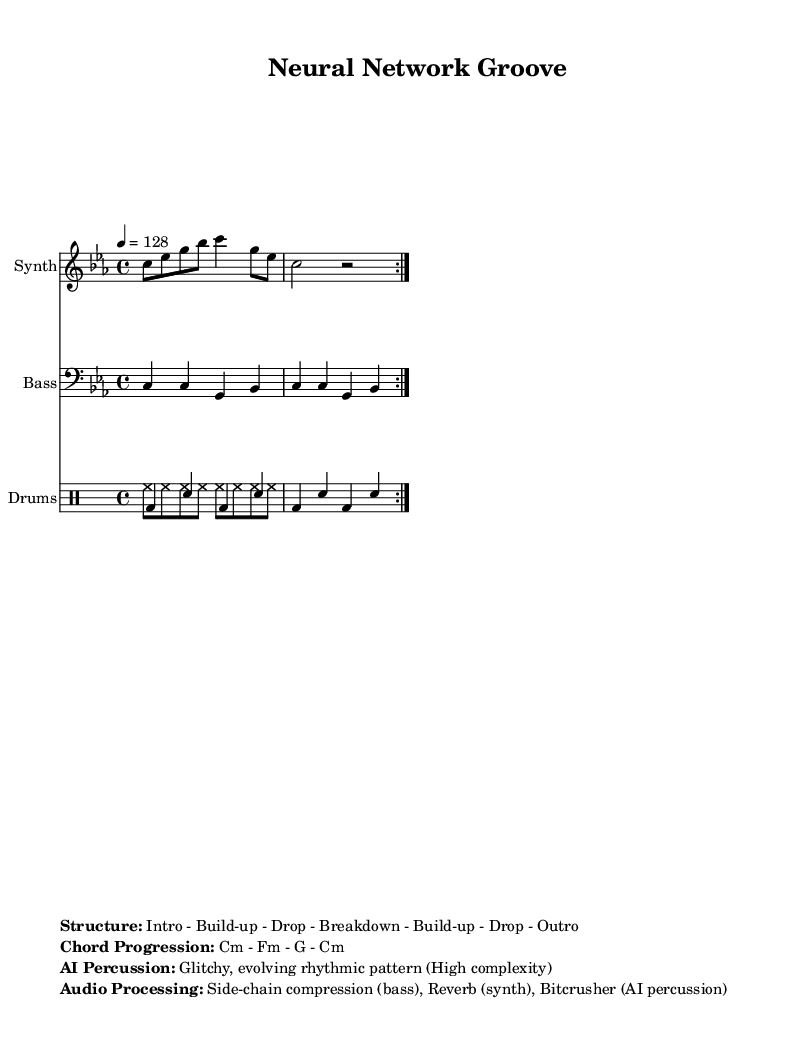What is the key signature of this music? The key is indicated by the symbol at the beginning of the staff. C minor has three flats in the key signature.
Answer: C minor What is the time signature of the piece? The time signature is represented by two numbers at the beginning of the score: 4 on top and 4 on the bottom. This means each measure contains four beats, and the quarter note receives one beat.
Answer: 4/4 What is the tempo marking for this track? The tempo marking appears at the top of the score, indicating how many beats per minute the piece should be played at. In this case, it shows 128 beats per minute.
Answer: 128 How many measures are in the Synth section before it repeats? The Synth section is indicated to repeat after two measures, which can be counted from the notation in the staff.
Answer: 2 What is the chord progression of the piece? The chord progression is listed in the markup section of the score, detailing the sequence of chords that underlie the harmony throughout the piece. It specifies Cm - Fm - G - Cm.
Answer: Cm - Fm - G - Cm What type of audio processing is used for the synth? The markup section describes the audio processing applied to the synth part. In this case, it mentions the use of reverb to enhance the sound.
Answer: Reverb What distinguishes the AI percussion in this music? The markup section notes the characteristics of the AI-generated percussion, describing it as having a glitchy and evolving rhythmic pattern, indicating its complexity and dynamic nature.
Answer: Glitchy, evolving rhythmic pattern 